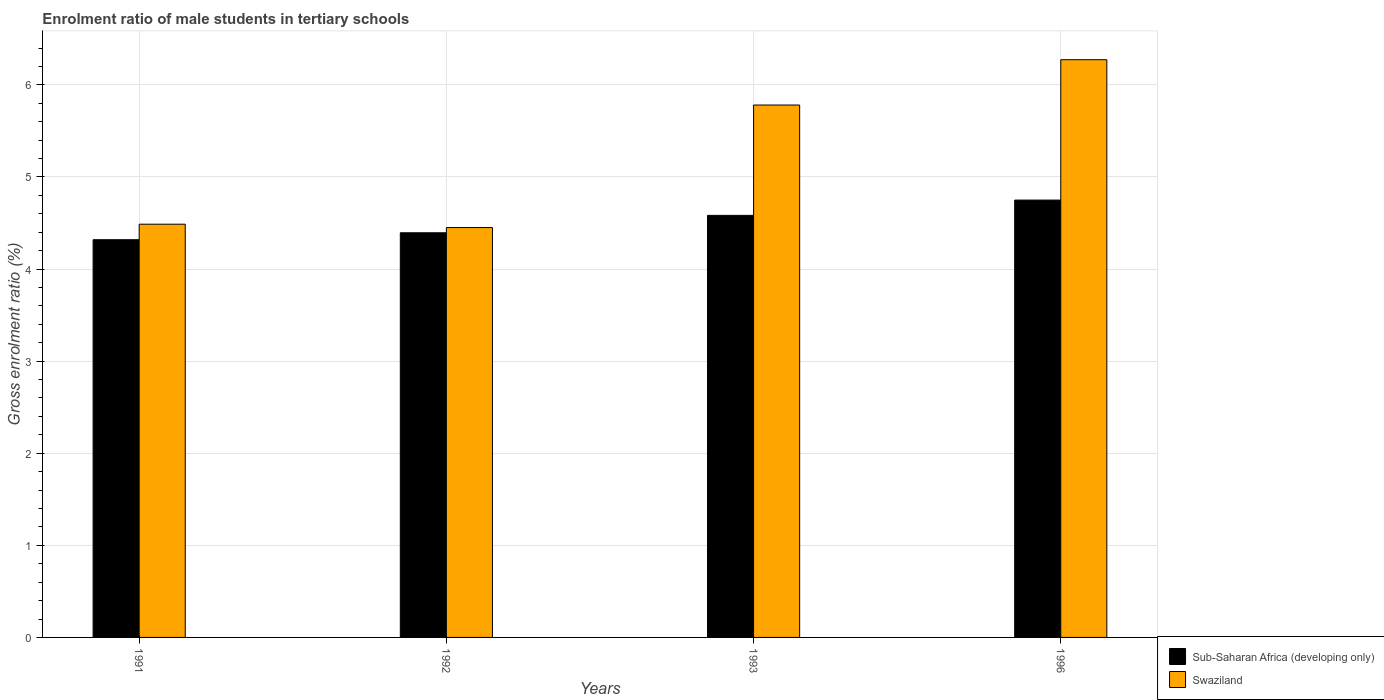How many groups of bars are there?
Keep it short and to the point. 4. Are the number of bars per tick equal to the number of legend labels?
Offer a very short reply. Yes. Are the number of bars on each tick of the X-axis equal?
Keep it short and to the point. Yes. How many bars are there on the 3rd tick from the left?
Offer a very short reply. 2. What is the label of the 2nd group of bars from the left?
Provide a succinct answer. 1992. In how many cases, is the number of bars for a given year not equal to the number of legend labels?
Provide a succinct answer. 0. What is the enrolment ratio of male students in tertiary schools in Sub-Saharan Africa (developing only) in 1996?
Offer a terse response. 4.75. Across all years, what is the maximum enrolment ratio of male students in tertiary schools in Sub-Saharan Africa (developing only)?
Offer a very short reply. 4.75. Across all years, what is the minimum enrolment ratio of male students in tertiary schools in Swaziland?
Offer a terse response. 4.45. What is the total enrolment ratio of male students in tertiary schools in Sub-Saharan Africa (developing only) in the graph?
Keep it short and to the point. 18.04. What is the difference between the enrolment ratio of male students in tertiary schools in Sub-Saharan Africa (developing only) in 1992 and that in 1993?
Offer a very short reply. -0.19. What is the difference between the enrolment ratio of male students in tertiary schools in Swaziland in 1992 and the enrolment ratio of male students in tertiary schools in Sub-Saharan Africa (developing only) in 1991?
Provide a succinct answer. 0.13. What is the average enrolment ratio of male students in tertiary schools in Swaziland per year?
Ensure brevity in your answer.  5.25. In the year 1996, what is the difference between the enrolment ratio of male students in tertiary schools in Swaziland and enrolment ratio of male students in tertiary schools in Sub-Saharan Africa (developing only)?
Offer a very short reply. 1.52. In how many years, is the enrolment ratio of male students in tertiary schools in Swaziland greater than 6 %?
Your response must be concise. 1. What is the ratio of the enrolment ratio of male students in tertiary schools in Swaziland in 1993 to that in 1996?
Offer a terse response. 0.92. Is the enrolment ratio of male students in tertiary schools in Swaziland in 1993 less than that in 1996?
Make the answer very short. Yes. Is the difference between the enrolment ratio of male students in tertiary schools in Swaziland in 1991 and 1993 greater than the difference between the enrolment ratio of male students in tertiary schools in Sub-Saharan Africa (developing only) in 1991 and 1993?
Your response must be concise. No. What is the difference between the highest and the second highest enrolment ratio of male students in tertiary schools in Sub-Saharan Africa (developing only)?
Keep it short and to the point. 0.17. What is the difference between the highest and the lowest enrolment ratio of male students in tertiary schools in Sub-Saharan Africa (developing only)?
Your answer should be compact. 0.43. In how many years, is the enrolment ratio of male students in tertiary schools in Sub-Saharan Africa (developing only) greater than the average enrolment ratio of male students in tertiary schools in Sub-Saharan Africa (developing only) taken over all years?
Provide a succinct answer. 2. What does the 1st bar from the left in 1996 represents?
Make the answer very short. Sub-Saharan Africa (developing only). What does the 1st bar from the right in 1993 represents?
Your answer should be compact. Swaziland. What is the difference between two consecutive major ticks on the Y-axis?
Make the answer very short. 1. Does the graph contain any zero values?
Provide a succinct answer. No. Does the graph contain grids?
Provide a short and direct response. Yes. How many legend labels are there?
Make the answer very short. 2. What is the title of the graph?
Provide a short and direct response. Enrolment ratio of male students in tertiary schools. What is the label or title of the Y-axis?
Keep it short and to the point. Gross enrolment ratio (%). What is the Gross enrolment ratio (%) in Sub-Saharan Africa (developing only) in 1991?
Ensure brevity in your answer.  4.32. What is the Gross enrolment ratio (%) in Swaziland in 1991?
Provide a short and direct response. 4.49. What is the Gross enrolment ratio (%) in Sub-Saharan Africa (developing only) in 1992?
Keep it short and to the point. 4.39. What is the Gross enrolment ratio (%) of Swaziland in 1992?
Ensure brevity in your answer.  4.45. What is the Gross enrolment ratio (%) of Sub-Saharan Africa (developing only) in 1993?
Your answer should be compact. 4.58. What is the Gross enrolment ratio (%) of Swaziland in 1993?
Keep it short and to the point. 5.78. What is the Gross enrolment ratio (%) in Sub-Saharan Africa (developing only) in 1996?
Offer a very short reply. 4.75. What is the Gross enrolment ratio (%) in Swaziland in 1996?
Ensure brevity in your answer.  6.27. Across all years, what is the maximum Gross enrolment ratio (%) of Sub-Saharan Africa (developing only)?
Make the answer very short. 4.75. Across all years, what is the maximum Gross enrolment ratio (%) of Swaziland?
Offer a very short reply. 6.27. Across all years, what is the minimum Gross enrolment ratio (%) in Sub-Saharan Africa (developing only)?
Offer a terse response. 4.32. Across all years, what is the minimum Gross enrolment ratio (%) in Swaziland?
Keep it short and to the point. 4.45. What is the total Gross enrolment ratio (%) of Sub-Saharan Africa (developing only) in the graph?
Your response must be concise. 18.04. What is the total Gross enrolment ratio (%) in Swaziland in the graph?
Your response must be concise. 20.99. What is the difference between the Gross enrolment ratio (%) in Sub-Saharan Africa (developing only) in 1991 and that in 1992?
Ensure brevity in your answer.  -0.08. What is the difference between the Gross enrolment ratio (%) of Swaziland in 1991 and that in 1992?
Your answer should be very brief. 0.04. What is the difference between the Gross enrolment ratio (%) in Sub-Saharan Africa (developing only) in 1991 and that in 1993?
Provide a short and direct response. -0.26. What is the difference between the Gross enrolment ratio (%) in Swaziland in 1991 and that in 1993?
Offer a very short reply. -1.29. What is the difference between the Gross enrolment ratio (%) of Sub-Saharan Africa (developing only) in 1991 and that in 1996?
Give a very brief answer. -0.43. What is the difference between the Gross enrolment ratio (%) of Swaziland in 1991 and that in 1996?
Ensure brevity in your answer.  -1.79. What is the difference between the Gross enrolment ratio (%) in Sub-Saharan Africa (developing only) in 1992 and that in 1993?
Ensure brevity in your answer.  -0.19. What is the difference between the Gross enrolment ratio (%) of Swaziland in 1992 and that in 1993?
Keep it short and to the point. -1.33. What is the difference between the Gross enrolment ratio (%) of Sub-Saharan Africa (developing only) in 1992 and that in 1996?
Your answer should be very brief. -0.35. What is the difference between the Gross enrolment ratio (%) of Swaziland in 1992 and that in 1996?
Offer a very short reply. -1.82. What is the difference between the Gross enrolment ratio (%) in Sub-Saharan Africa (developing only) in 1993 and that in 1996?
Keep it short and to the point. -0.17. What is the difference between the Gross enrolment ratio (%) in Swaziland in 1993 and that in 1996?
Offer a very short reply. -0.49. What is the difference between the Gross enrolment ratio (%) in Sub-Saharan Africa (developing only) in 1991 and the Gross enrolment ratio (%) in Swaziland in 1992?
Your response must be concise. -0.13. What is the difference between the Gross enrolment ratio (%) of Sub-Saharan Africa (developing only) in 1991 and the Gross enrolment ratio (%) of Swaziland in 1993?
Your response must be concise. -1.46. What is the difference between the Gross enrolment ratio (%) in Sub-Saharan Africa (developing only) in 1991 and the Gross enrolment ratio (%) in Swaziland in 1996?
Make the answer very short. -1.95. What is the difference between the Gross enrolment ratio (%) of Sub-Saharan Africa (developing only) in 1992 and the Gross enrolment ratio (%) of Swaziland in 1993?
Ensure brevity in your answer.  -1.39. What is the difference between the Gross enrolment ratio (%) of Sub-Saharan Africa (developing only) in 1992 and the Gross enrolment ratio (%) of Swaziland in 1996?
Provide a succinct answer. -1.88. What is the difference between the Gross enrolment ratio (%) of Sub-Saharan Africa (developing only) in 1993 and the Gross enrolment ratio (%) of Swaziland in 1996?
Ensure brevity in your answer.  -1.69. What is the average Gross enrolment ratio (%) of Sub-Saharan Africa (developing only) per year?
Ensure brevity in your answer.  4.51. What is the average Gross enrolment ratio (%) in Swaziland per year?
Ensure brevity in your answer.  5.25. In the year 1991, what is the difference between the Gross enrolment ratio (%) of Sub-Saharan Africa (developing only) and Gross enrolment ratio (%) of Swaziland?
Your response must be concise. -0.17. In the year 1992, what is the difference between the Gross enrolment ratio (%) of Sub-Saharan Africa (developing only) and Gross enrolment ratio (%) of Swaziland?
Provide a short and direct response. -0.06. In the year 1993, what is the difference between the Gross enrolment ratio (%) of Sub-Saharan Africa (developing only) and Gross enrolment ratio (%) of Swaziland?
Give a very brief answer. -1.2. In the year 1996, what is the difference between the Gross enrolment ratio (%) in Sub-Saharan Africa (developing only) and Gross enrolment ratio (%) in Swaziland?
Offer a terse response. -1.52. What is the ratio of the Gross enrolment ratio (%) in Sub-Saharan Africa (developing only) in 1991 to that in 1992?
Provide a short and direct response. 0.98. What is the ratio of the Gross enrolment ratio (%) of Swaziland in 1991 to that in 1992?
Provide a short and direct response. 1.01. What is the ratio of the Gross enrolment ratio (%) in Sub-Saharan Africa (developing only) in 1991 to that in 1993?
Ensure brevity in your answer.  0.94. What is the ratio of the Gross enrolment ratio (%) of Swaziland in 1991 to that in 1993?
Provide a succinct answer. 0.78. What is the ratio of the Gross enrolment ratio (%) of Sub-Saharan Africa (developing only) in 1991 to that in 1996?
Your response must be concise. 0.91. What is the ratio of the Gross enrolment ratio (%) in Swaziland in 1991 to that in 1996?
Make the answer very short. 0.72. What is the ratio of the Gross enrolment ratio (%) in Sub-Saharan Africa (developing only) in 1992 to that in 1993?
Your answer should be compact. 0.96. What is the ratio of the Gross enrolment ratio (%) of Swaziland in 1992 to that in 1993?
Offer a very short reply. 0.77. What is the ratio of the Gross enrolment ratio (%) of Sub-Saharan Africa (developing only) in 1992 to that in 1996?
Your answer should be very brief. 0.93. What is the ratio of the Gross enrolment ratio (%) in Swaziland in 1992 to that in 1996?
Your answer should be very brief. 0.71. What is the ratio of the Gross enrolment ratio (%) in Sub-Saharan Africa (developing only) in 1993 to that in 1996?
Ensure brevity in your answer.  0.97. What is the ratio of the Gross enrolment ratio (%) in Swaziland in 1993 to that in 1996?
Your answer should be compact. 0.92. What is the difference between the highest and the second highest Gross enrolment ratio (%) of Sub-Saharan Africa (developing only)?
Ensure brevity in your answer.  0.17. What is the difference between the highest and the second highest Gross enrolment ratio (%) of Swaziland?
Provide a short and direct response. 0.49. What is the difference between the highest and the lowest Gross enrolment ratio (%) in Sub-Saharan Africa (developing only)?
Your answer should be compact. 0.43. What is the difference between the highest and the lowest Gross enrolment ratio (%) of Swaziland?
Provide a short and direct response. 1.82. 